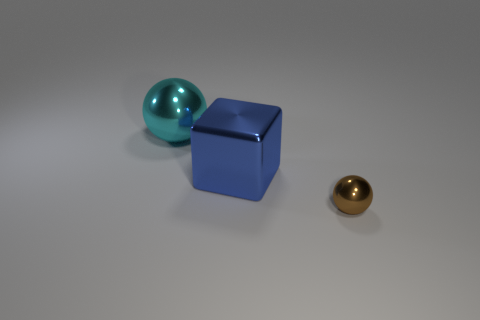Add 1 cyan rubber cubes. How many objects exist? 4 Subtract all cubes. How many objects are left? 2 Add 3 large yellow metal things. How many large yellow metal things exist? 3 Subtract 0 blue spheres. How many objects are left? 3 Subtract all small brown shiny objects. Subtract all big cyan metal objects. How many objects are left? 1 Add 2 big cyan metallic things. How many big cyan metallic things are left? 3 